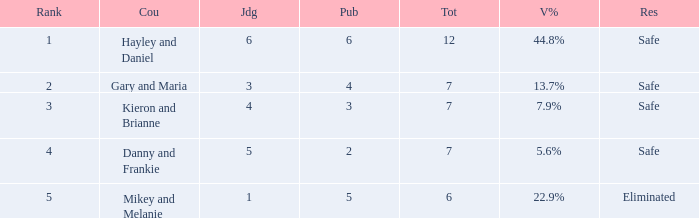What was the maximum rank for the vote percentage of 5.6% 4.0. Could you parse the entire table as a dict? {'header': ['Rank', 'Cou', 'Jdg', 'Pub', 'Tot', 'V%', 'Res'], 'rows': [['1', 'Hayley and Daniel', '6', '6', '12', '44.8%', 'Safe'], ['2', 'Gary and Maria', '3', '4', '7', '13.7%', 'Safe'], ['3', 'Kieron and Brianne', '4', '3', '7', '7.9%', 'Safe'], ['4', 'Danny and Frankie', '5', '2', '7', '5.6%', 'Safe'], ['5', 'Mikey and Melanie', '1', '5', '6', '22.9%', 'Eliminated']]} 